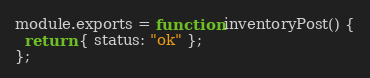<code> <loc_0><loc_0><loc_500><loc_500><_JavaScript_>module.exports = function inventoryPost() {
  return { status: "ok" };
};
</code> 